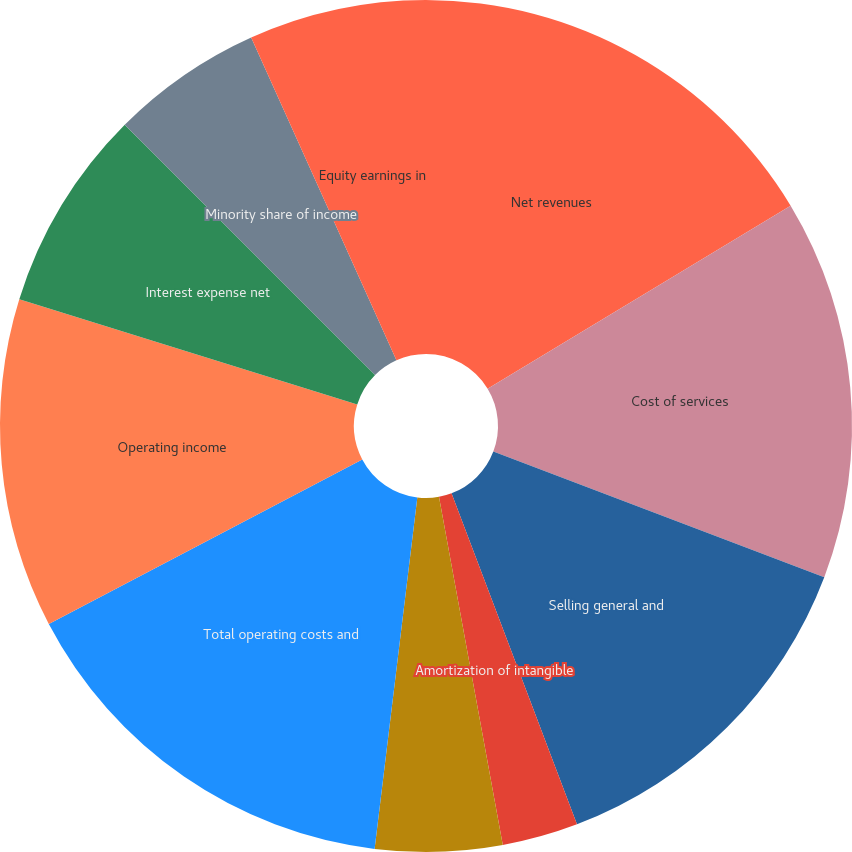Convert chart. <chart><loc_0><loc_0><loc_500><loc_500><pie_chart><fcel>Net revenues<fcel>Cost of services<fcel>Selling general and<fcel>Amortization of intangible<fcel>Other operating expense<fcel>Total operating costs and<fcel>Operating income<fcel>Interest expense net<fcel>Minority share of income<fcel>Equity earnings in<nl><fcel>16.35%<fcel>14.42%<fcel>13.46%<fcel>2.88%<fcel>4.81%<fcel>15.38%<fcel>12.5%<fcel>7.69%<fcel>5.77%<fcel>6.73%<nl></chart> 